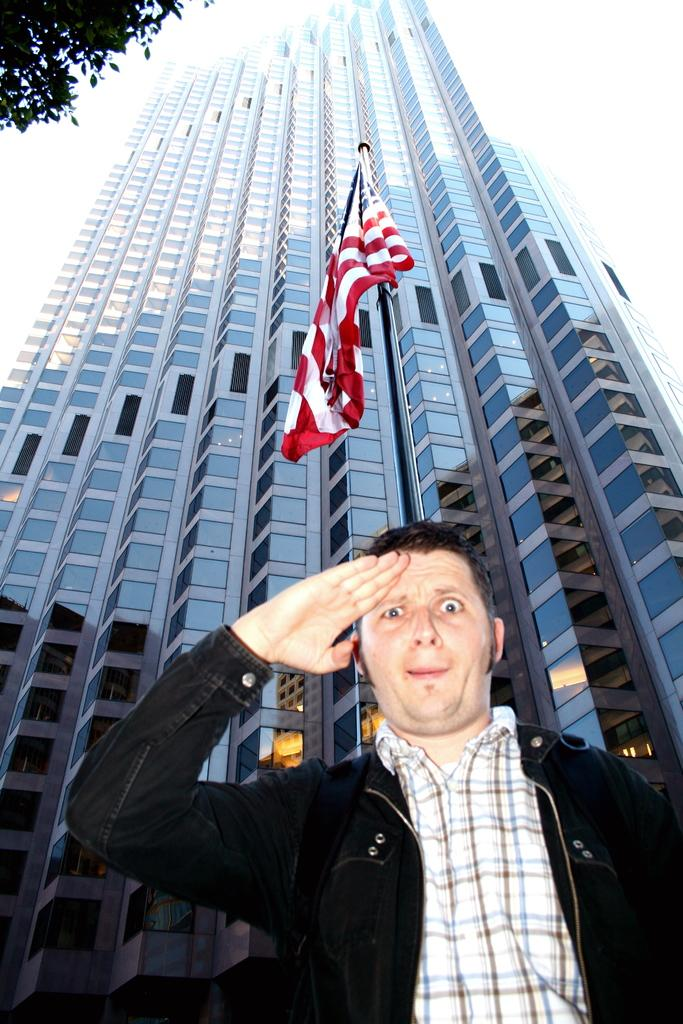What is the main subject of the image? There is a man standing in the image. What is the man wearing? The man is wearing a jacket. What else can be seen in the image besides the man? There is a flag, a building, a tree, and the sky visible in the image. What type of prison can be seen in the image? There is no prison present in the image. What kind of treatment is being administered to the man in the image? There is no indication of any treatment being administered to the man in the image. 